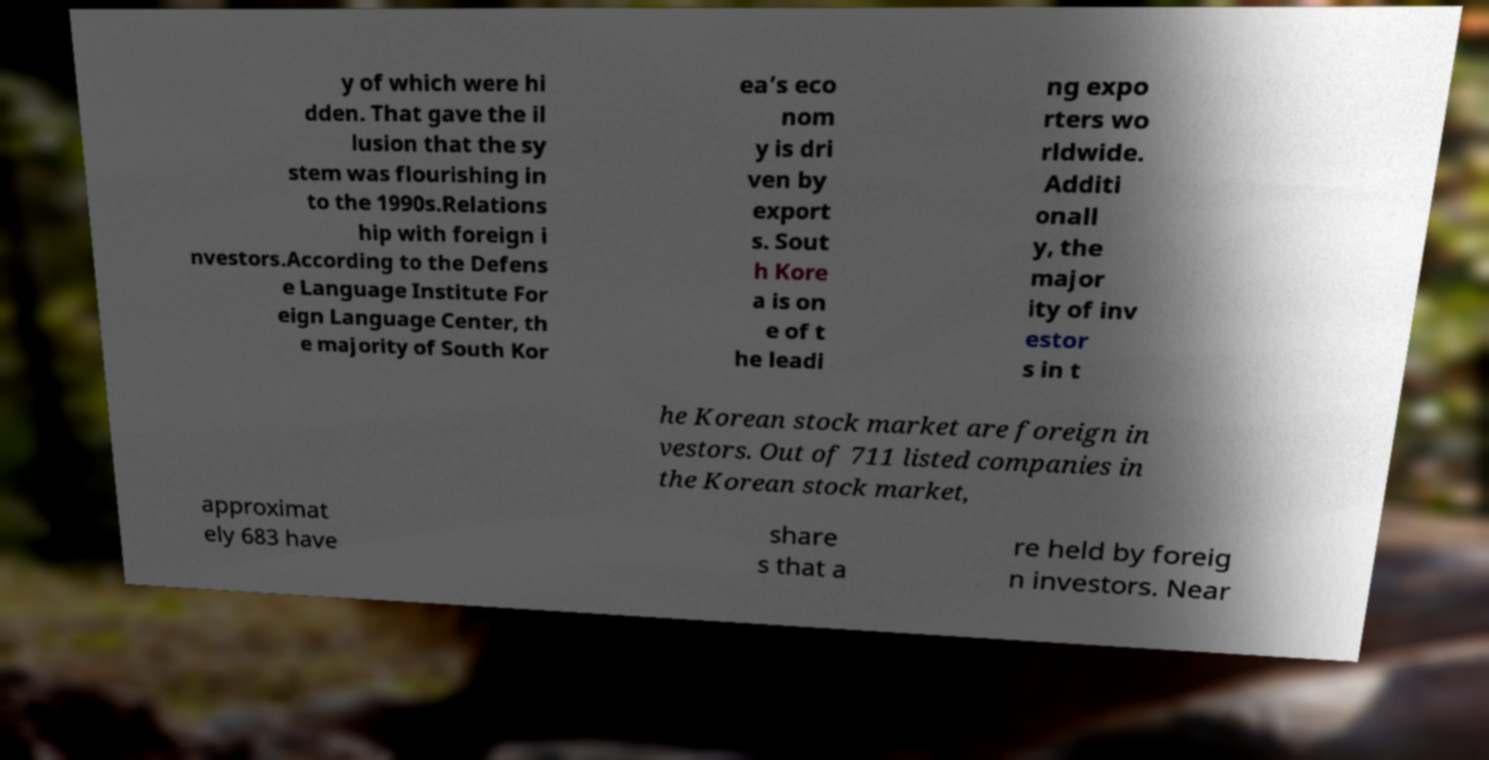Could you assist in decoding the text presented in this image and type it out clearly? y of which were hi dden. That gave the il lusion that the sy stem was flourishing in to the 1990s.Relations hip with foreign i nvestors.According to the Defens e Language Institute For eign Language Center, th e majority of South Kor ea’s eco nom y is dri ven by export s. Sout h Kore a is on e of t he leadi ng expo rters wo rldwide. Additi onall y, the major ity of inv estor s in t he Korean stock market are foreign in vestors. Out of 711 listed companies in the Korean stock market, approximat ely 683 have share s that a re held by foreig n investors. Near 